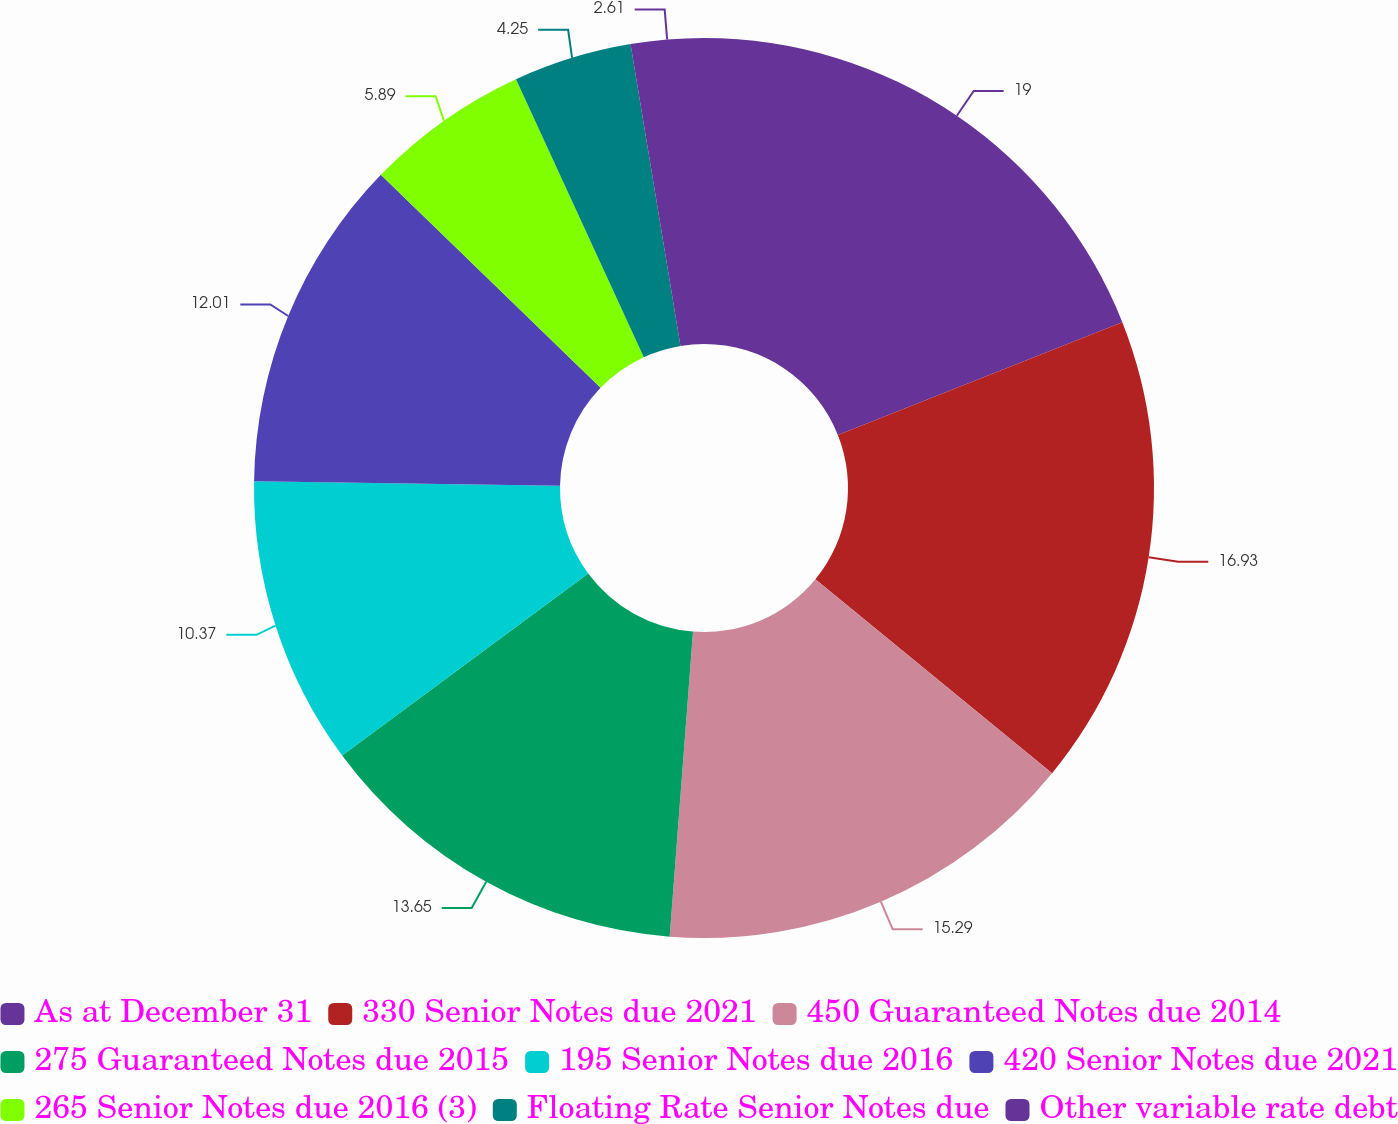<chart> <loc_0><loc_0><loc_500><loc_500><pie_chart><fcel>As at December 31<fcel>330 Senior Notes due 2021<fcel>450 Guaranteed Notes due 2014<fcel>275 Guaranteed Notes due 2015<fcel>195 Senior Notes due 2016<fcel>420 Senior Notes due 2021<fcel>265 Senior Notes due 2016 (3)<fcel>Floating Rate Senior Notes due<fcel>Other variable rate debt<nl><fcel>18.99%<fcel>16.93%<fcel>15.29%<fcel>13.65%<fcel>10.37%<fcel>12.01%<fcel>5.89%<fcel>4.25%<fcel>2.61%<nl></chart> 